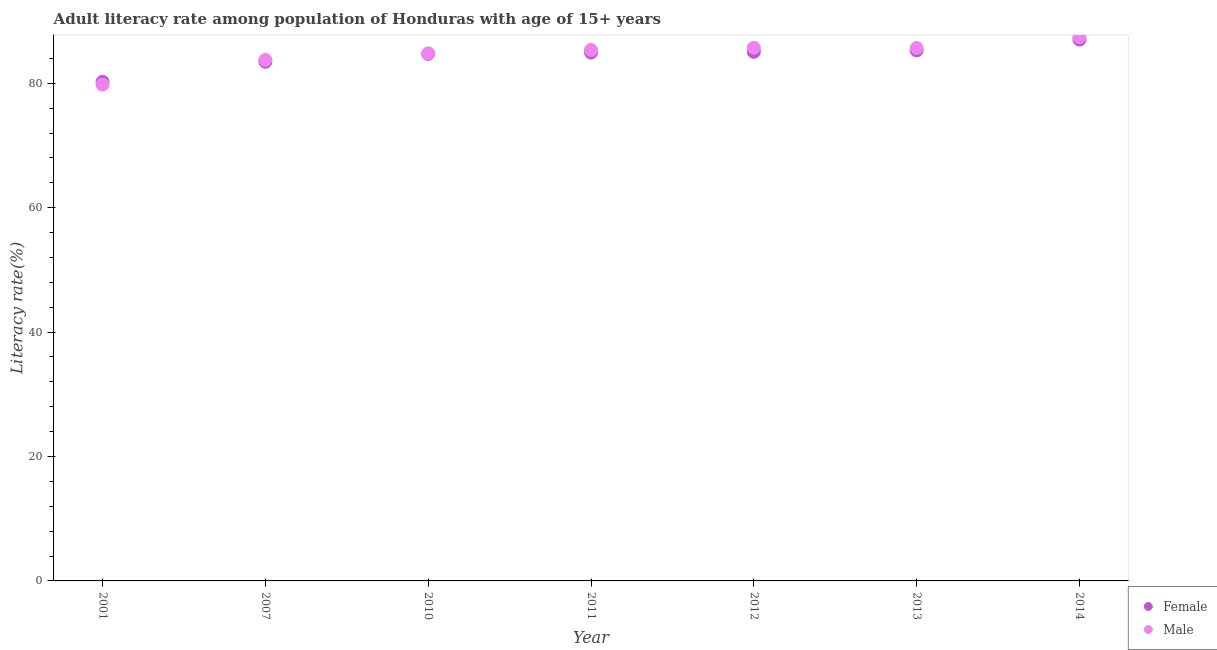How many different coloured dotlines are there?
Ensure brevity in your answer.  2. What is the female adult literacy rate in 2001?
Your answer should be compact. 80.22. Across all years, what is the maximum male adult literacy rate?
Ensure brevity in your answer.  87.4. Across all years, what is the minimum male adult literacy rate?
Your answer should be very brief. 79.79. In which year was the female adult literacy rate maximum?
Provide a short and direct response. 2014. What is the total male adult literacy rate in the graph?
Your answer should be compact. 592.42. What is the difference between the male adult literacy rate in 2010 and that in 2013?
Provide a succinct answer. -0.88. What is the difference between the female adult literacy rate in 2007 and the male adult literacy rate in 2010?
Your answer should be very brief. -1.34. What is the average female adult literacy rate per year?
Provide a short and direct response. 84.38. In the year 2012, what is the difference between the female adult literacy rate and male adult literacy rate?
Your answer should be very brief. -0.64. In how many years, is the female adult literacy rate greater than 16 %?
Offer a terse response. 7. What is the ratio of the male adult literacy rate in 2001 to that in 2013?
Give a very brief answer. 0.93. Is the male adult literacy rate in 2012 less than that in 2014?
Your answer should be very brief. Yes. What is the difference between the highest and the second highest female adult literacy rate?
Offer a very short reply. 1.74. What is the difference between the highest and the lowest male adult literacy rate?
Make the answer very short. 7.61. In how many years, is the female adult literacy rate greater than the average female adult literacy rate taken over all years?
Your answer should be compact. 5. Does the graph contain any zero values?
Your answer should be compact. No. Does the graph contain grids?
Your answer should be compact. No. How many legend labels are there?
Your answer should be compact. 2. How are the legend labels stacked?
Your answer should be compact. Vertical. What is the title of the graph?
Provide a short and direct response. Adult literacy rate among population of Honduras with age of 15+ years. What is the label or title of the X-axis?
Give a very brief answer. Year. What is the label or title of the Y-axis?
Ensure brevity in your answer.  Literacy rate(%). What is the Literacy rate(%) of Female in 2001?
Offer a very short reply. 80.22. What is the Literacy rate(%) of Male in 2001?
Make the answer very short. 79.79. What is the Literacy rate(%) of Female in 2007?
Your answer should be very brief. 83.45. What is the Literacy rate(%) in Male in 2007?
Give a very brief answer. 83.75. What is the Literacy rate(%) in Female in 2010?
Provide a short and direct response. 84.73. What is the Literacy rate(%) in Male in 2010?
Your answer should be very brief. 84.79. What is the Literacy rate(%) of Female in 2011?
Your answer should be compact. 84.93. What is the Literacy rate(%) of Male in 2011?
Ensure brevity in your answer.  85.34. What is the Literacy rate(%) in Female in 2012?
Make the answer very short. 85.05. What is the Literacy rate(%) of Male in 2012?
Provide a short and direct response. 85.7. What is the Literacy rate(%) in Female in 2013?
Keep it short and to the point. 85.28. What is the Literacy rate(%) in Male in 2013?
Your answer should be very brief. 85.67. What is the Literacy rate(%) in Female in 2014?
Ensure brevity in your answer.  87.03. What is the Literacy rate(%) in Male in 2014?
Provide a short and direct response. 87.4. Across all years, what is the maximum Literacy rate(%) in Female?
Offer a very short reply. 87.03. Across all years, what is the maximum Literacy rate(%) of Male?
Provide a short and direct response. 87.4. Across all years, what is the minimum Literacy rate(%) of Female?
Your response must be concise. 80.22. Across all years, what is the minimum Literacy rate(%) in Male?
Your answer should be very brief. 79.79. What is the total Literacy rate(%) of Female in the graph?
Make the answer very short. 590.69. What is the total Literacy rate(%) of Male in the graph?
Give a very brief answer. 592.42. What is the difference between the Literacy rate(%) of Female in 2001 and that in 2007?
Give a very brief answer. -3.23. What is the difference between the Literacy rate(%) of Male in 2001 and that in 2007?
Make the answer very short. -3.96. What is the difference between the Literacy rate(%) in Female in 2001 and that in 2010?
Give a very brief answer. -4.5. What is the difference between the Literacy rate(%) in Male in 2001 and that in 2010?
Offer a terse response. -5. What is the difference between the Literacy rate(%) in Female in 2001 and that in 2011?
Provide a succinct answer. -4.71. What is the difference between the Literacy rate(%) of Male in 2001 and that in 2011?
Ensure brevity in your answer.  -5.56. What is the difference between the Literacy rate(%) in Female in 2001 and that in 2012?
Provide a succinct answer. -4.83. What is the difference between the Literacy rate(%) in Male in 2001 and that in 2012?
Make the answer very short. -5.91. What is the difference between the Literacy rate(%) of Female in 2001 and that in 2013?
Offer a very short reply. -5.06. What is the difference between the Literacy rate(%) in Male in 2001 and that in 2013?
Ensure brevity in your answer.  -5.88. What is the difference between the Literacy rate(%) in Female in 2001 and that in 2014?
Offer a very short reply. -6.8. What is the difference between the Literacy rate(%) of Male in 2001 and that in 2014?
Keep it short and to the point. -7.61. What is the difference between the Literacy rate(%) in Female in 2007 and that in 2010?
Your response must be concise. -1.27. What is the difference between the Literacy rate(%) of Male in 2007 and that in 2010?
Keep it short and to the point. -1.04. What is the difference between the Literacy rate(%) of Female in 2007 and that in 2011?
Your answer should be compact. -1.48. What is the difference between the Literacy rate(%) of Male in 2007 and that in 2011?
Keep it short and to the point. -1.6. What is the difference between the Literacy rate(%) of Female in 2007 and that in 2012?
Provide a succinct answer. -1.6. What is the difference between the Literacy rate(%) of Male in 2007 and that in 2012?
Your answer should be compact. -1.95. What is the difference between the Literacy rate(%) in Female in 2007 and that in 2013?
Provide a succinct answer. -1.83. What is the difference between the Literacy rate(%) in Male in 2007 and that in 2013?
Make the answer very short. -1.92. What is the difference between the Literacy rate(%) of Female in 2007 and that in 2014?
Make the answer very short. -3.57. What is the difference between the Literacy rate(%) in Male in 2007 and that in 2014?
Your response must be concise. -3.65. What is the difference between the Literacy rate(%) in Female in 2010 and that in 2011?
Provide a succinct answer. -0.21. What is the difference between the Literacy rate(%) of Male in 2010 and that in 2011?
Ensure brevity in your answer.  -0.55. What is the difference between the Literacy rate(%) of Female in 2010 and that in 2012?
Make the answer very short. -0.33. What is the difference between the Literacy rate(%) in Male in 2010 and that in 2012?
Your response must be concise. -0.91. What is the difference between the Literacy rate(%) in Female in 2010 and that in 2013?
Keep it short and to the point. -0.56. What is the difference between the Literacy rate(%) in Male in 2010 and that in 2013?
Ensure brevity in your answer.  -0.88. What is the difference between the Literacy rate(%) of Female in 2010 and that in 2014?
Provide a short and direct response. -2.3. What is the difference between the Literacy rate(%) in Male in 2010 and that in 2014?
Offer a terse response. -2.61. What is the difference between the Literacy rate(%) of Female in 2011 and that in 2012?
Keep it short and to the point. -0.12. What is the difference between the Literacy rate(%) in Male in 2011 and that in 2012?
Make the answer very short. -0.35. What is the difference between the Literacy rate(%) of Female in 2011 and that in 2013?
Your answer should be compact. -0.35. What is the difference between the Literacy rate(%) in Male in 2011 and that in 2013?
Your answer should be compact. -0.33. What is the difference between the Literacy rate(%) of Female in 2011 and that in 2014?
Offer a very short reply. -2.1. What is the difference between the Literacy rate(%) in Male in 2011 and that in 2014?
Offer a terse response. -2.05. What is the difference between the Literacy rate(%) in Female in 2012 and that in 2013?
Your response must be concise. -0.23. What is the difference between the Literacy rate(%) in Male in 2012 and that in 2013?
Your response must be concise. 0.03. What is the difference between the Literacy rate(%) of Female in 2012 and that in 2014?
Provide a succinct answer. -1.97. What is the difference between the Literacy rate(%) of Male in 2012 and that in 2014?
Give a very brief answer. -1.7. What is the difference between the Literacy rate(%) of Female in 2013 and that in 2014?
Provide a succinct answer. -1.74. What is the difference between the Literacy rate(%) in Male in 2013 and that in 2014?
Offer a terse response. -1.73. What is the difference between the Literacy rate(%) in Female in 2001 and the Literacy rate(%) in Male in 2007?
Your response must be concise. -3.52. What is the difference between the Literacy rate(%) of Female in 2001 and the Literacy rate(%) of Male in 2010?
Your answer should be very brief. -4.57. What is the difference between the Literacy rate(%) of Female in 2001 and the Literacy rate(%) of Male in 2011?
Provide a short and direct response. -5.12. What is the difference between the Literacy rate(%) of Female in 2001 and the Literacy rate(%) of Male in 2012?
Make the answer very short. -5.47. What is the difference between the Literacy rate(%) of Female in 2001 and the Literacy rate(%) of Male in 2013?
Make the answer very short. -5.44. What is the difference between the Literacy rate(%) of Female in 2001 and the Literacy rate(%) of Male in 2014?
Your answer should be very brief. -7.17. What is the difference between the Literacy rate(%) in Female in 2007 and the Literacy rate(%) in Male in 2010?
Your response must be concise. -1.34. What is the difference between the Literacy rate(%) of Female in 2007 and the Literacy rate(%) of Male in 2011?
Provide a succinct answer. -1.89. What is the difference between the Literacy rate(%) in Female in 2007 and the Literacy rate(%) in Male in 2012?
Your answer should be very brief. -2.24. What is the difference between the Literacy rate(%) in Female in 2007 and the Literacy rate(%) in Male in 2013?
Ensure brevity in your answer.  -2.22. What is the difference between the Literacy rate(%) in Female in 2007 and the Literacy rate(%) in Male in 2014?
Provide a short and direct response. -3.94. What is the difference between the Literacy rate(%) of Female in 2010 and the Literacy rate(%) of Male in 2011?
Offer a terse response. -0.62. What is the difference between the Literacy rate(%) of Female in 2010 and the Literacy rate(%) of Male in 2012?
Your answer should be very brief. -0.97. What is the difference between the Literacy rate(%) in Female in 2010 and the Literacy rate(%) in Male in 2013?
Your response must be concise. -0.94. What is the difference between the Literacy rate(%) in Female in 2010 and the Literacy rate(%) in Male in 2014?
Give a very brief answer. -2.67. What is the difference between the Literacy rate(%) of Female in 2011 and the Literacy rate(%) of Male in 2012?
Provide a succinct answer. -0.77. What is the difference between the Literacy rate(%) in Female in 2011 and the Literacy rate(%) in Male in 2013?
Ensure brevity in your answer.  -0.74. What is the difference between the Literacy rate(%) of Female in 2011 and the Literacy rate(%) of Male in 2014?
Ensure brevity in your answer.  -2.47. What is the difference between the Literacy rate(%) in Female in 2012 and the Literacy rate(%) in Male in 2013?
Offer a very short reply. -0.62. What is the difference between the Literacy rate(%) in Female in 2012 and the Literacy rate(%) in Male in 2014?
Keep it short and to the point. -2.34. What is the difference between the Literacy rate(%) of Female in 2013 and the Literacy rate(%) of Male in 2014?
Ensure brevity in your answer.  -2.11. What is the average Literacy rate(%) in Female per year?
Provide a short and direct response. 84.38. What is the average Literacy rate(%) of Male per year?
Make the answer very short. 84.63. In the year 2001, what is the difference between the Literacy rate(%) of Female and Literacy rate(%) of Male?
Your response must be concise. 0.44. In the year 2007, what is the difference between the Literacy rate(%) in Female and Literacy rate(%) in Male?
Provide a short and direct response. -0.29. In the year 2010, what is the difference between the Literacy rate(%) of Female and Literacy rate(%) of Male?
Offer a terse response. -0.06. In the year 2011, what is the difference between the Literacy rate(%) in Female and Literacy rate(%) in Male?
Offer a terse response. -0.41. In the year 2012, what is the difference between the Literacy rate(%) of Female and Literacy rate(%) of Male?
Provide a short and direct response. -0.64. In the year 2013, what is the difference between the Literacy rate(%) of Female and Literacy rate(%) of Male?
Ensure brevity in your answer.  -0.38. In the year 2014, what is the difference between the Literacy rate(%) in Female and Literacy rate(%) in Male?
Give a very brief answer. -0.37. What is the ratio of the Literacy rate(%) in Female in 2001 to that in 2007?
Offer a very short reply. 0.96. What is the ratio of the Literacy rate(%) of Male in 2001 to that in 2007?
Offer a terse response. 0.95. What is the ratio of the Literacy rate(%) in Female in 2001 to that in 2010?
Keep it short and to the point. 0.95. What is the ratio of the Literacy rate(%) in Male in 2001 to that in 2010?
Make the answer very short. 0.94. What is the ratio of the Literacy rate(%) in Female in 2001 to that in 2011?
Offer a terse response. 0.94. What is the ratio of the Literacy rate(%) of Male in 2001 to that in 2011?
Provide a succinct answer. 0.93. What is the ratio of the Literacy rate(%) in Female in 2001 to that in 2012?
Provide a short and direct response. 0.94. What is the ratio of the Literacy rate(%) of Male in 2001 to that in 2012?
Ensure brevity in your answer.  0.93. What is the ratio of the Literacy rate(%) in Female in 2001 to that in 2013?
Provide a succinct answer. 0.94. What is the ratio of the Literacy rate(%) of Male in 2001 to that in 2013?
Provide a succinct answer. 0.93. What is the ratio of the Literacy rate(%) in Female in 2001 to that in 2014?
Offer a terse response. 0.92. What is the ratio of the Literacy rate(%) of Male in 2001 to that in 2014?
Provide a succinct answer. 0.91. What is the ratio of the Literacy rate(%) in Female in 2007 to that in 2010?
Ensure brevity in your answer.  0.98. What is the ratio of the Literacy rate(%) in Male in 2007 to that in 2010?
Your answer should be very brief. 0.99. What is the ratio of the Literacy rate(%) of Female in 2007 to that in 2011?
Provide a succinct answer. 0.98. What is the ratio of the Literacy rate(%) of Male in 2007 to that in 2011?
Offer a terse response. 0.98. What is the ratio of the Literacy rate(%) of Female in 2007 to that in 2012?
Ensure brevity in your answer.  0.98. What is the ratio of the Literacy rate(%) of Male in 2007 to that in 2012?
Offer a terse response. 0.98. What is the ratio of the Literacy rate(%) in Female in 2007 to that in 2013?
Provide a short and direct response. 0.98. What is the ratio of the Literacy rate(%) in Male in 2007 to that in 2013?
Your answer should be compact. 0.98. What is the ratio of the Literacy rate(%) of Female in 2007 to that in 2014?
Your answer should be compact. 0.96. What is the ratio of the Literacy rate(%) of Male in 2007 to that in 2014?
Make the answer very short. 0.96. What is the ratio of the Literacy rate(%) in Female in 2010 to that in 2011?
Make the answer very short. 1. What is the ratio of the Literacy rate(%) of Female in 2010 to that in 2012?
Offer a terse response. 1. What is the ratio of the Literacy rate(%) in Female in 2010 to that in 2013?
Provide a succinct answer. 0.99. What is the ratio of the Literacy rate(%) of Female in 2010 to that in 2014?
Provide a short and direct response. 0.97. What is the ratio of the Literacy rate(%) of Male in 2010 to that in 2014?
Provide a succinct answer. 0.97. What is the ratio of the Literacy rate(%) of Female in 2011 to that in 2012?
Your answer should be very brief. 1. What is the ratio of the Literacy rate(%) of Female in 2011 to that in 2013?
Your answer should be very brief. 1. What is the ratio of the Literacy rate(%) of Male in 2011 to that in 2013?
Provide a succinct answer. 1. What is the ratio of the Literacy rate(%) in Female in 2011 to that in 2014?
Offer a very short reply. 0.98. What is the ratio of the Literacy rate(%) in Male in 2011 to that in 2014?
Your answer should be very brief. 0.98. What is the ratio of the Literacy rate(%) of Female in 2012 to that in 2013?
Your answer should be very brief. 1. What is the ratio of the Literacy rate(%) of Male in 2012 to that in 2013?
Keep it short and to the point. 1. What is the ratio of the Literacy rate(%) in Female in 2012 to that in 2014?
Your response must be concise. 0.98. What is the ratio of the Literacy rate(%) in Male in 2012 to that in 2014?
Make the answer very short. 0.98. What is the ratio of the Literacy rate(%) of Male in 2013 to that in 2014?
Your response must be concise. 0.98. What is the difference between the highest and the second highest Literacy rate(%) of Female?
Make the answer very short. 1.74. What is the difference between the highest and the second highest Literacy rate(%) of Male?
Your answer should be compact. 1.7. What is the difference between the highest and the lowest Literacy rate(%) of Female?
Your answer should be compact. 6.8. What is the difference between the highest and the lowest Literacy rate(%) of Male?
Your answer should be very brief. 7.61. 